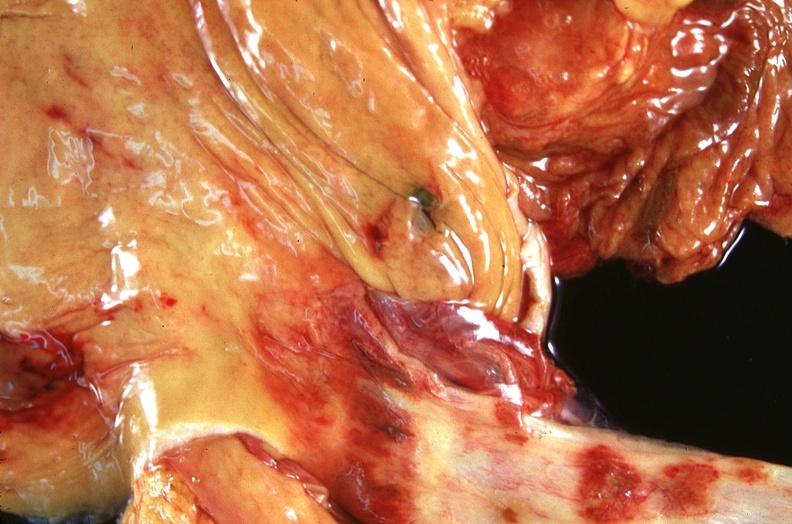what does this image show?
Answer the question using a single word or phrase. Stomach and esophagus 